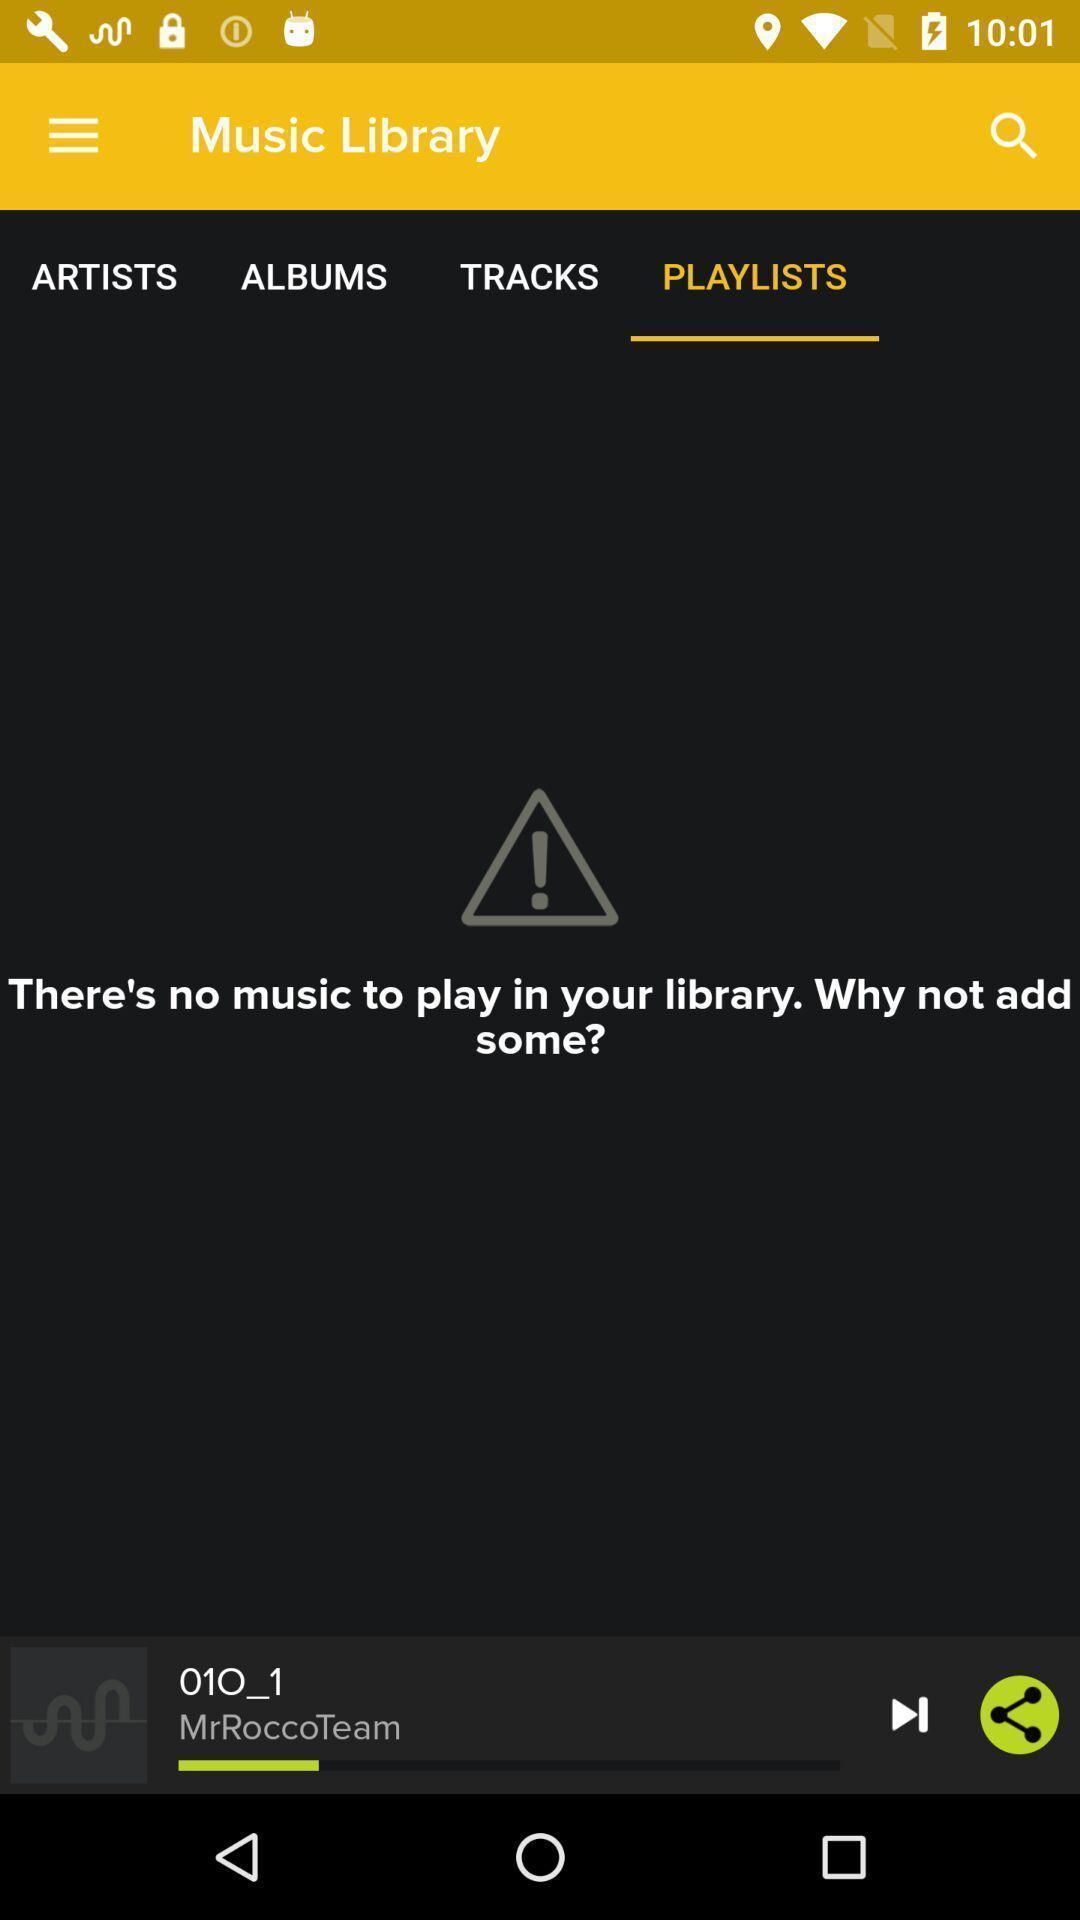Describe the key features of this screenshot. Screen displaying multiple options in a music application. 